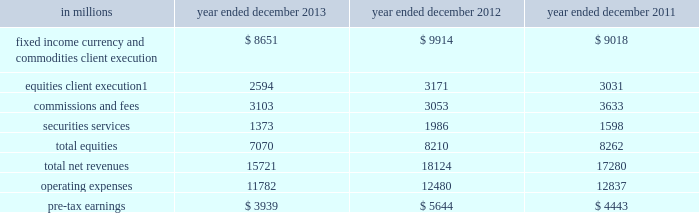Management 2019s discussion and analysis institutional client services our institutional client services segment is comprised of : fixed income , currency and commodities client execution .
Includes client execution activities related to making markets in interest rate products , credit products , mortgages , currencies and commodities .
We generate market-making revenues in these activities in three ways : 2030 in large , highly liquid markets ( such as markets for u.s .
Treasury bills or certain mortgage pass-through certificates ) , we execute a high volume of transactions for our clients for modest spreads and fees .
2030 in less liquid markets ( such as mid-cap corporate bonds , growth market currencies or certain non-agency mortgage-backed securities ) , we execute transactions for our clients for spreads and fees that are generally somewhat larger .
2030 we also structure and execute transactions involving customized or tailor-made products that address our clients 2019 risk exposures , investment objectives or other complex needs ( such as a jet fuel hedge for an airline ) .
Given the focus on the mortgage market , our mortgage activities are further described below .
Our activities in mortgages include commercial mortgage- related securities , loans and derivatives , residential mortgage-related securities , loans and derivatives ( including u.s .
Government agency-issued collateralized mortgage obligations , other prime , subprime and alt-a securities and loans ) , and other asset-backed securities , loans and derivatives .
We buy , hold and sell long and short mortgage positions , primarily for market making for our clients .
Our inventory therefore changes based on client demands and is generally held for short-term periods .
See notes 18 and 27 to the consolidated financial statements for information about exposure to mortgage repurchase requests , mortgage rescissions and mortgage-related litigation .
Equities .
Includes client execution activities related to making markets in equity products and commissions and fees from executing and clearing institutional client transactions on major stock , options and futures exchanges worldwide , as well as over-the-counter transactions .
Equities also includes our securities services business , which provides financing , securities lending and other prime brokerage services to institutional clients , including hedge funds , mutual funds , pension funds and foundations , and generates revenues primarily in the form of interest rate spreads or fees .
The table below presents the operating results of our institutional client services segment. .
In april 2013 , we completed the sale of a majority stake in our americas reinsurance business and no longer consolidate this business .
Net revenues related to the americas reinsurance business were $ 317 million for 2013 , $ 1.08 billion for 2012 and $ 880 million for 2011 .
See note 12 to the consolidated financial statements for further information about this sale .
2013 versus 2012 .
Net revenues in institutional client services were $ 15.72 billion for 2013 , 13% ( 13 % ) lower than 2012 .
Net revenues in fixed income , currency and commodities client execution were $ 8.65 billion for 2013 , 13% ( 13 % ) lower than 2012 , reflecting significantly lower net revenues in interest rate products compared with a solid 2012 , and significantly lower net revenues in mortgages compared with a strong 2012 .
The decrease in interest rate products and mortgages primarily reflected the impact of a more challenging environment and lower activity levels compared with 2012 .
In addition , net revenues in currencies were slightly lower , while net revenues in credit products and commodities were essentially unchanged compared with 2012 .
In december 2013 , we completed the sale of a majority stake in our european insurance business and recognized a gain of $ 211 million .
50 goldman sachs 2013 annual report .
What percentage of total net revenues institutional client services segment in 2013 were made up of equities client execution? 
Computations: (2594 / 15721)
Answer: 0.165. 